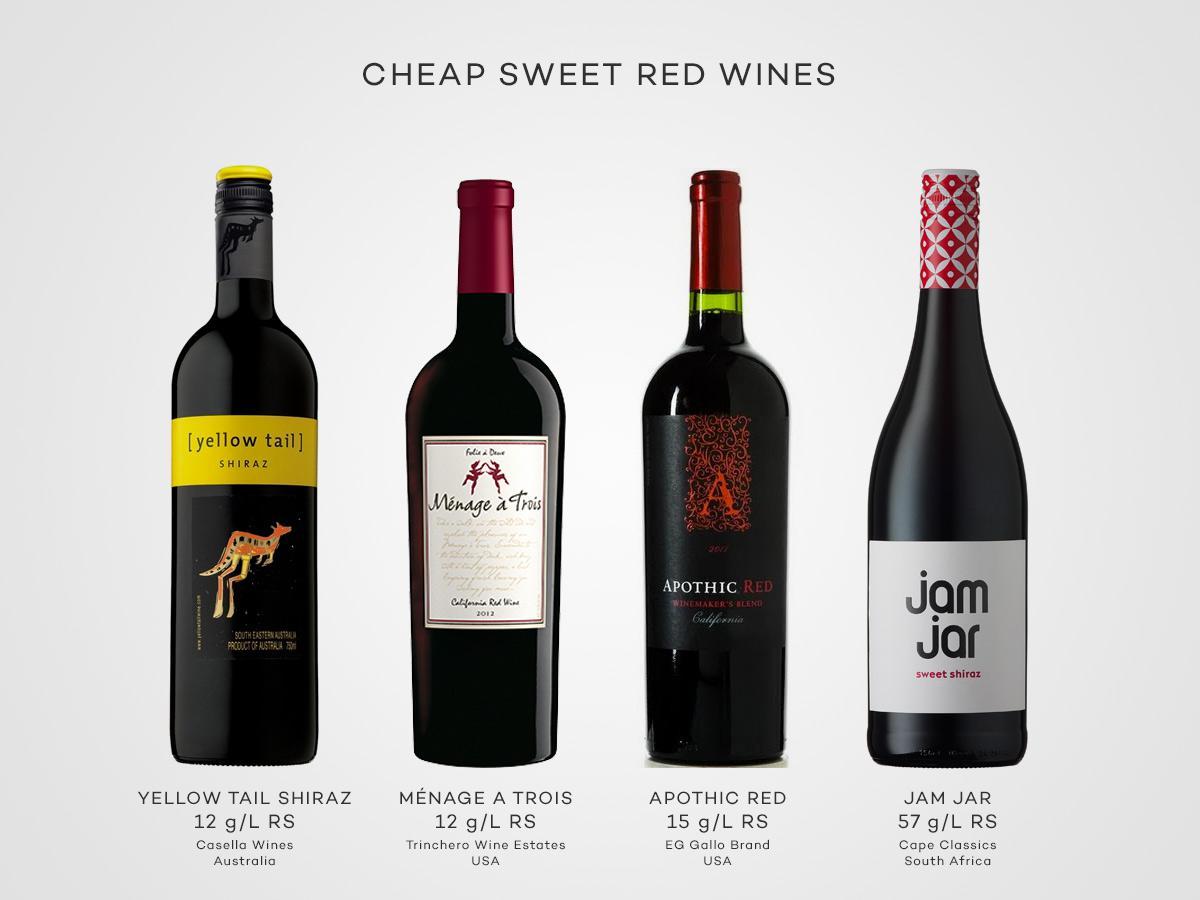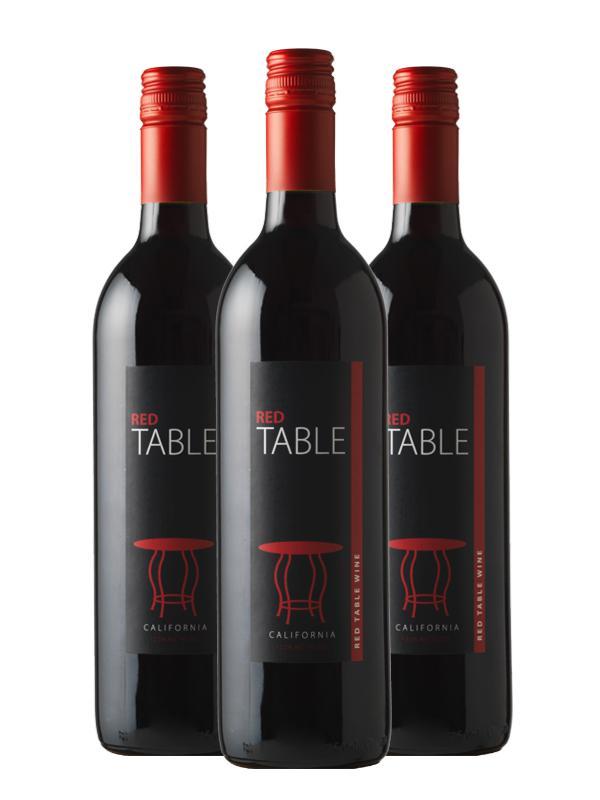The first image is the image on the left, the second image is the image on the right. Considering the images on both sides, is "Exactly three bottles are displayed in a level row with none of them touching or overlapping." valid? Answer yes or no. No. The first image is the image on the left, the second image is the image on the right. Considering the images on both sides, is "The left image contains exactly four bottles of wine." valid? Answer yes or no. Yes. 